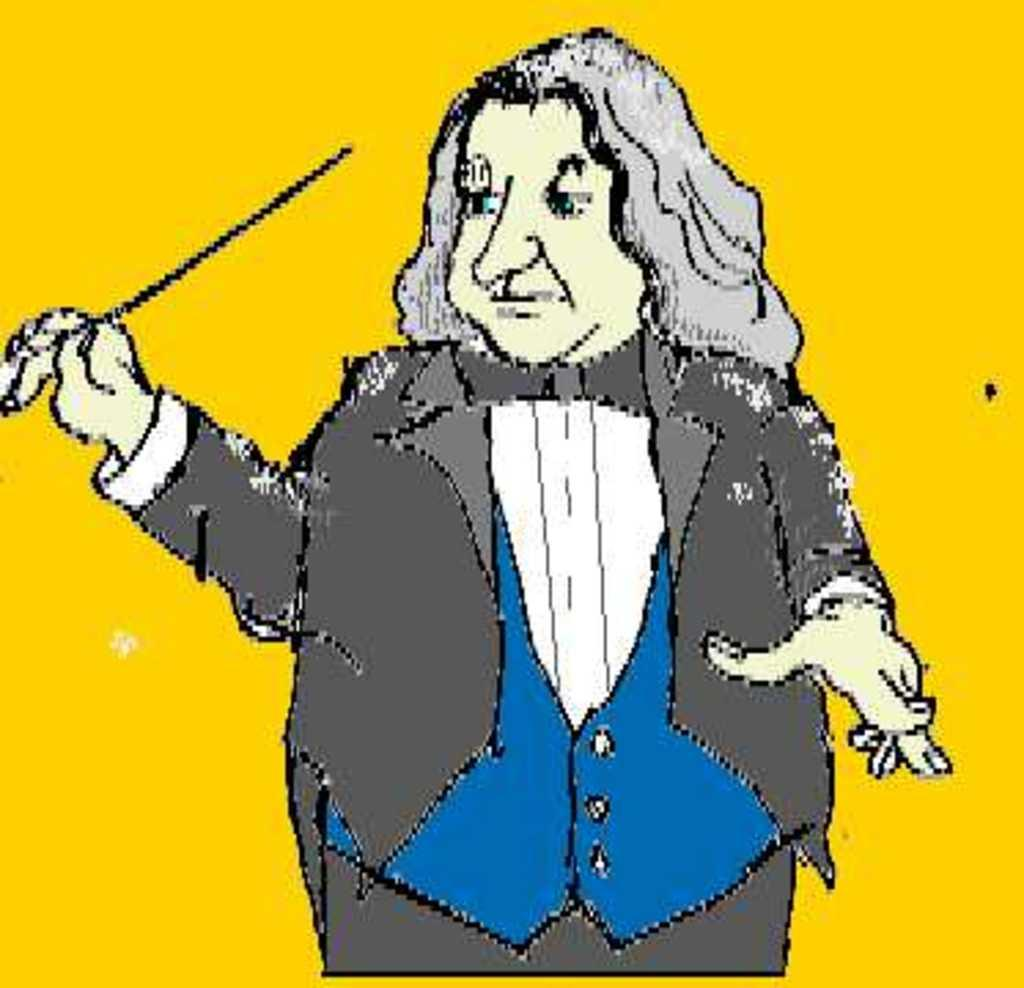How would you describe the style of the image? The image is edited and cartoon-like. Can you describe the main subject in the image? There is a person standing in the center of the image. What is the person holding in the image? The person is holding a stick. What type of marble is the person sitting on in the image? There is no marble present in the image, and the person is standing, not sitting. 